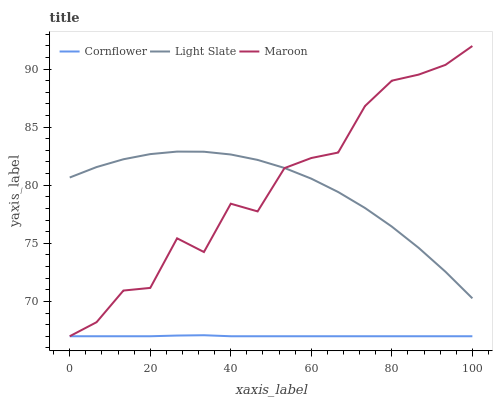Does Cornflower have the minimum area under the curve?
Answer yes or no. Yes. Does Maroon have the maximum area under the curve?
Answer yes or no. Yes. Does Maroon have the minimum area under the curve?
Answer yes or no. No. Does Cornflower have the maximum area under the curve?
Answer yes or no. No. Is Cornflower the smoothest?
Answer yes or no. Yes. Is Maroon the roughest?
Answer yes or no. Yes. Is Maroon the smoothest?
Answer yes or no. No. Is Cornflower the roughest?
Answer yes or no. No. Does Cornflower have the lowest value?
Answer yes or no. Yes. Does Maroon have the highest value?
Answer yes or no. Yes. Does Cornflower have the highest value?
Answer yes or no. No. Is Cornflower less than Light Slate?
Answer yes or no. Yes. Is Light Slate greater than Cornflower?
Answer yes or no. Yes. Does Cornflower intersect Maroon?
Answer yes or no. Yes. Is Cornflower less than Maroon?
Answer yes or no. No. Is Cornflower greater than Maroon?
Answer yes or no. No. Does Cornflower intersect Light Slate?
Answer yes or no. No. 